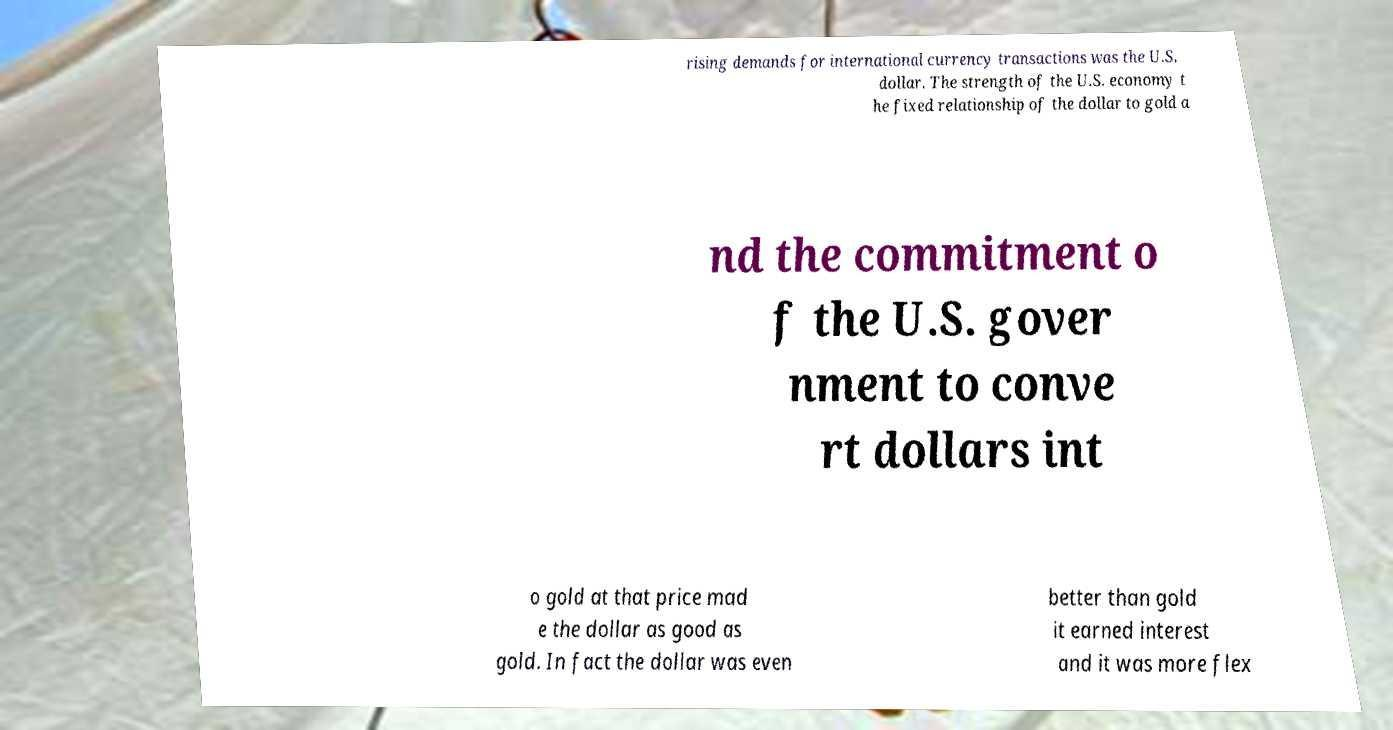Please read and relay the text visible in this image. What does it say? rising demands for international currency transactions was the U.S. dollar. The strength of the U.S. economy t he fixed relationship of the dollar to gold a nd the commitment o f the U.S. gover nment to conve rt dollars int o gold at that price mad e the dollar as good as gold. In fact the dollar was even better than gold it earned interest and it was more flex 